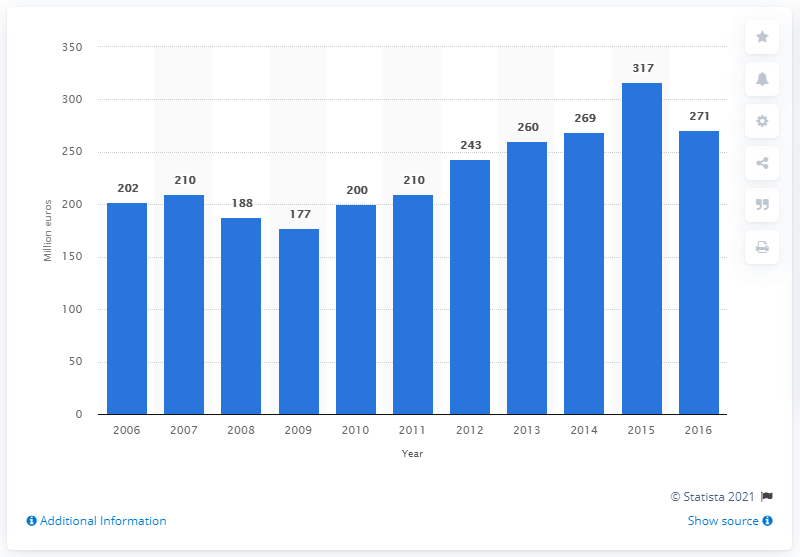Specify some key components in this picture. In 2014, the net sales of the Reebok-CCM Hockey brand were 271 million dollars. 